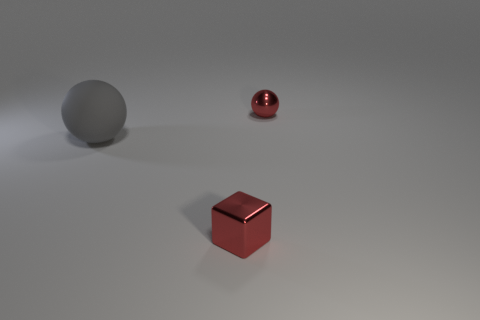Add 1 metal balls. How many objects exist? 4 Subtract all blocks. How many objects are left? 2 Add 2 large gray things. How many large gray things are left? 3 Add 2 metal cubes. How many metal cubes exist? 3 Subtract 0 purple spheres. How many objects are left? 3 Subtract all tiny spheres. Subtract all large purple matte cubes. How many objects are left? 2 